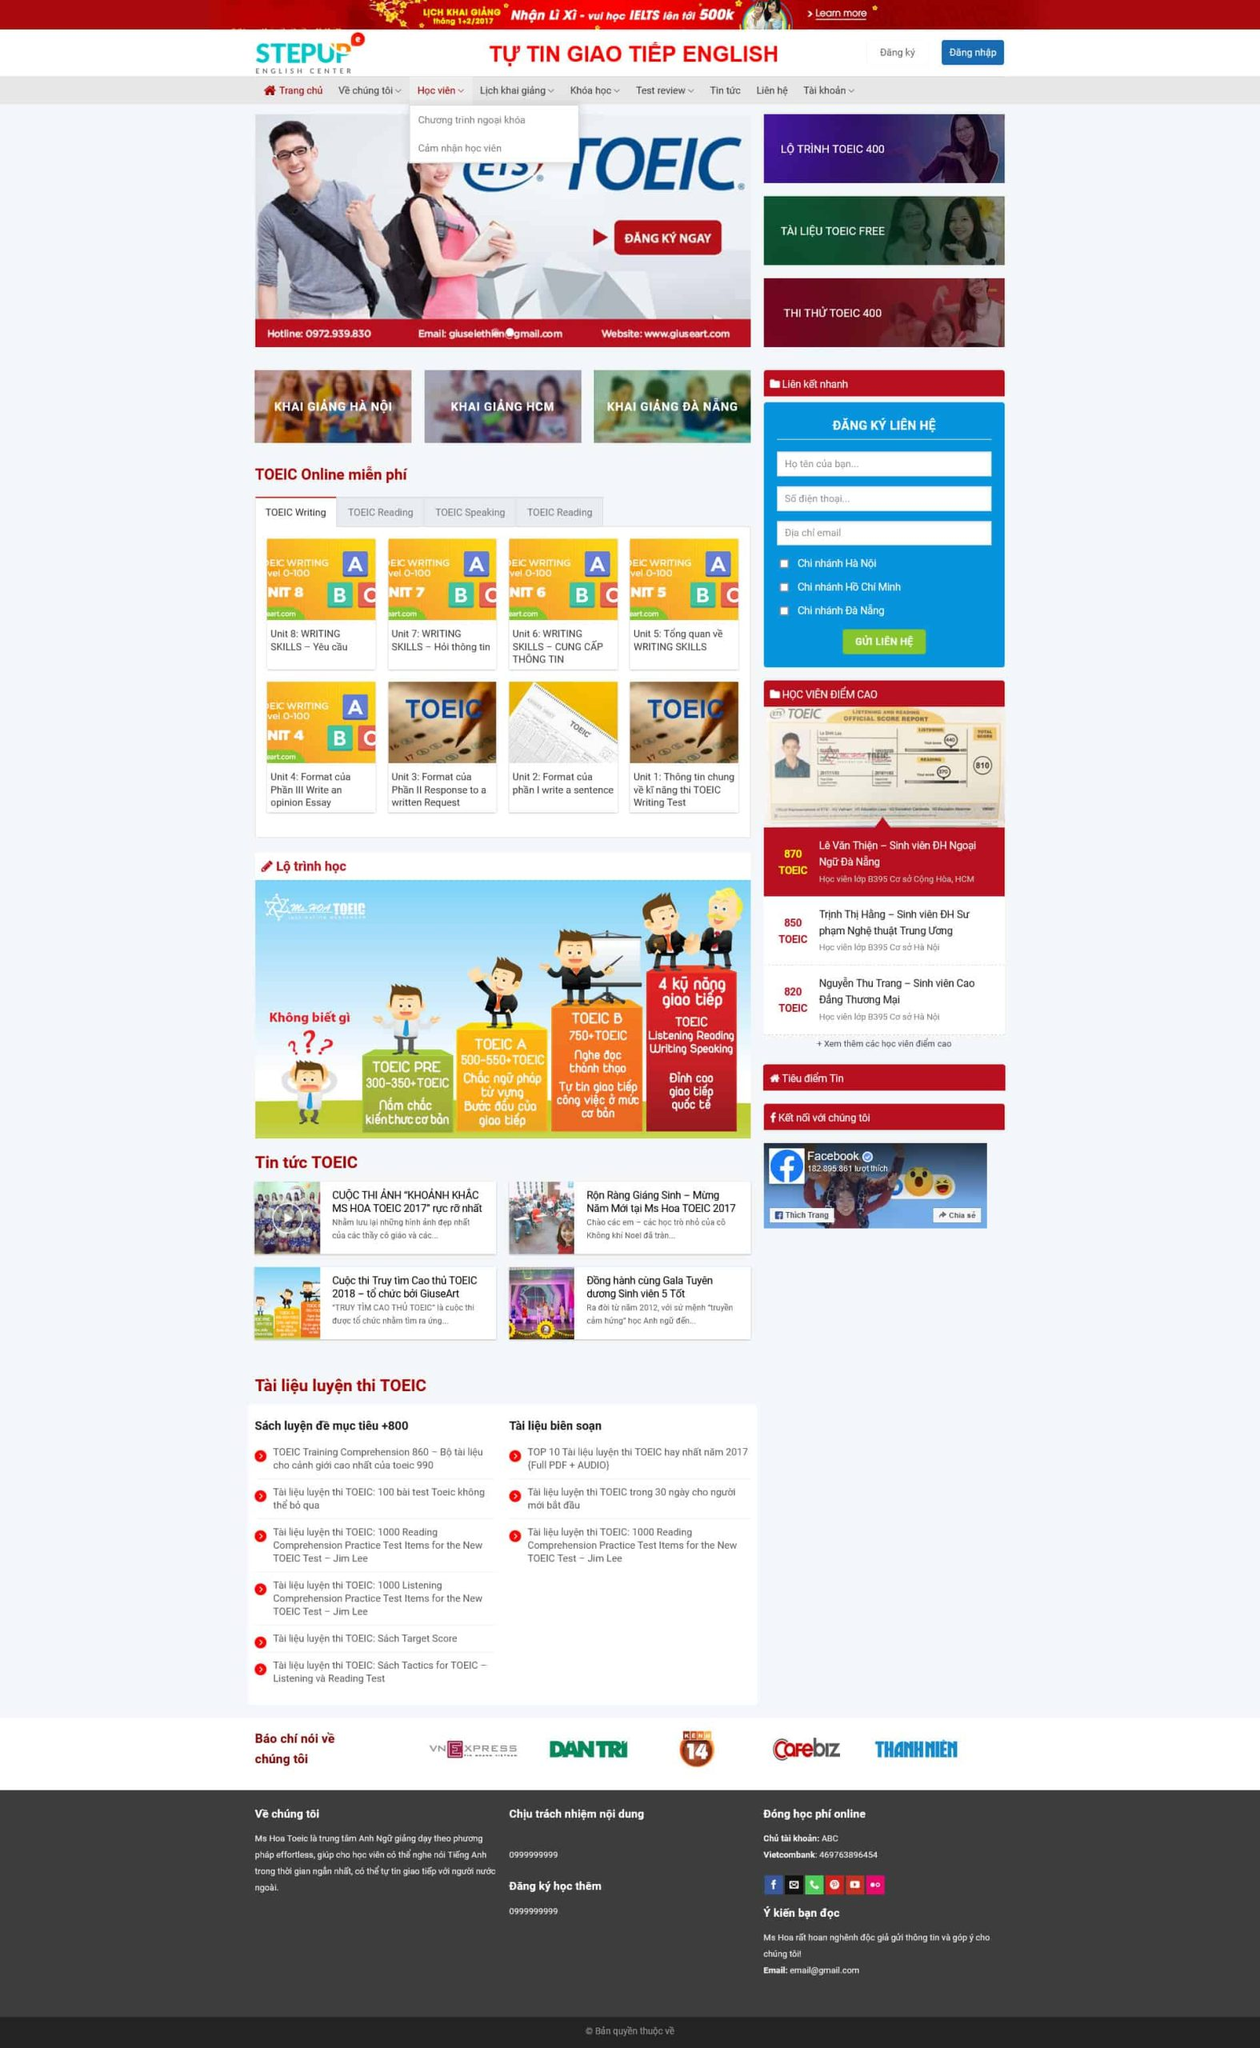Liệt kê 5 ngành nghề, lĩnh vực phù hợp với website này, phân cách các màu sắc bằng dấu phẩy. Chỉ trả về kết quả, phân cách bằng dấy phẩy
 Giáo dục, đào tạo ngoại ngữ, luyện thi, tư vấn du học, tài liệu học tập 